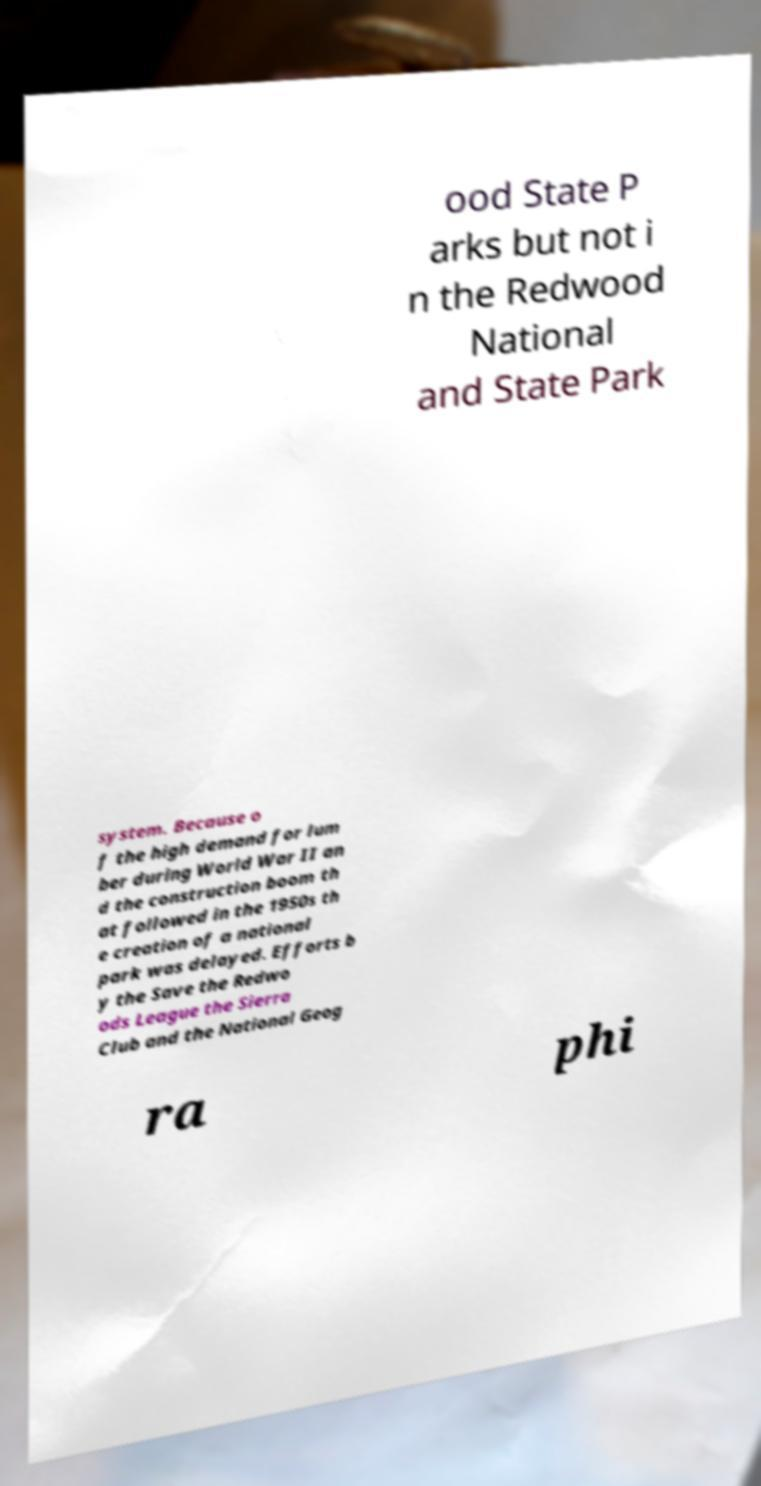I need the written content from this picture converted into text. Can you do that? ood State P arks but not i n the Redwood National and State Park system. Because o f the high demand for lum ber during World War II an d the construction boom th at followed in the 1950s th e creation of a national park was delayed. Efforts b y the Save the Redwo ods League the Sierra Club and the National Geog ra phi 